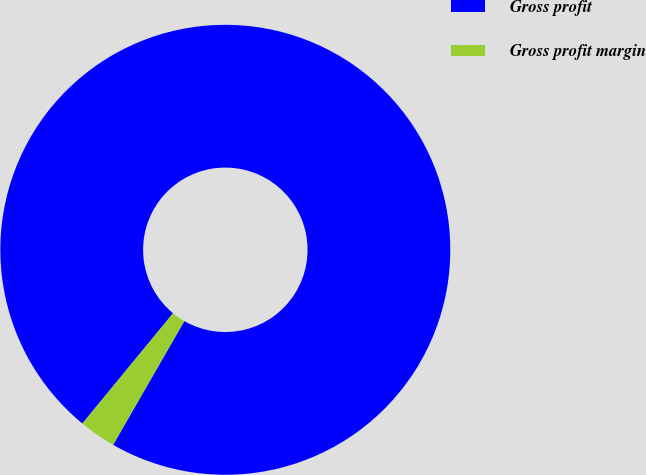Convert chart. <chart><loc_0><loc_0><loc_500><loc_500><pie_chart><fcel>Gross profit<fcel>Gross profit margin<nl><fcel>97.35%<fcel>2.65%<nl></chart> 